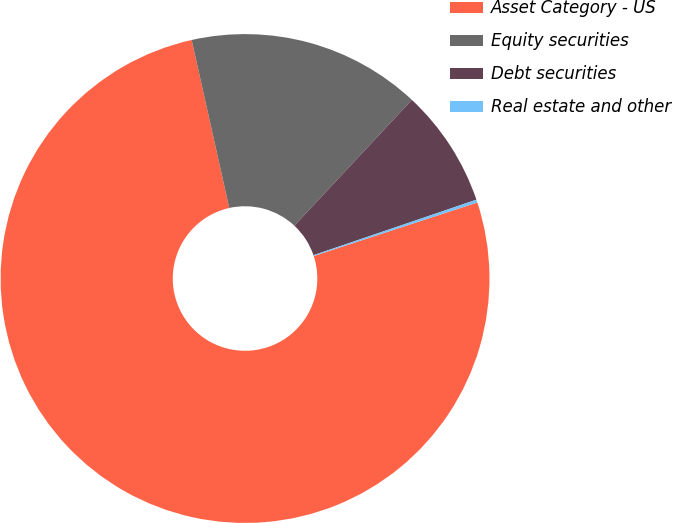Convert chart. <chart><loc_0><loc_0><loc_500><loc_500><pie_chart><fcel>Asset Category - US<fcel>Equity securities<fcel>Debt securities<fcel>Real estate and other<nl><fcel>76.53%<fcel>15.46%<fcel>7.82%<fcel>0.19%<nl></chart> 